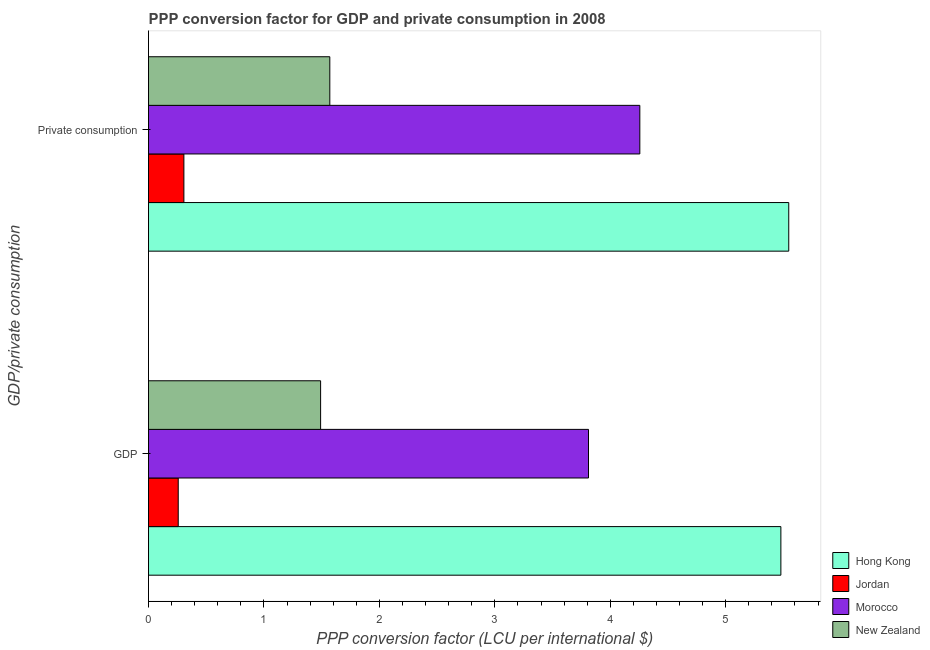How many different coloured bars are there?
Make the answer very short. 4. What is the label of the 1st group of bars from the top?
Your answer should be compact.  Private consumption. What is the ppp conversion factor for private consumption in Hong Kong?
Keep it short and to the point. 5.55. Across all countries, what is the maximum ppp conversion factor for private consumption?
Keep it short and to the point. 5.55. Across all countries, what is the minimum ppp conversion factor for private consumption?
Make the answer very short. 0.31. In which country was the ppp conversion factor for gdp maximum?
Offer a terse response. Hong Kong. In which country was the ppp conversion factor for gdp minimum?
Offer a very short reply. Jordan. What is the total ppp conversion factor for private consumption in the graph?
Offer a very short reply. 11.68. What is the difference between the ppp conversion factor for private consumption in New Zealand and that in Hong Kong?
Make the answer very short. -3.98. What is the difference between the ppp conversion factor for private consumption in Hong Kong and the ppp conversion factor for gdp in Jordan?
Your answer should be very brief. 5.29. What is the average ppp conversion factor for private consumption per country?
Give a very brief answer. 2.92. What is the difference between the ppp conversion factor for private consumption and ppp conversion factor for gdp in Hong Kong?
Offer a terse response. 0.07. In how many countries, is the ppp conversion factor for private consumption greater than 4.4 LCU?
Provide a succinct answer. 1. What is the ratio of the ppp conversion factor for private consumption in Jordan to that in New Zealand?
Make the answer very short. 0.2. In how many countries, is the ppp conversion factor for gdp greater than the average ppp conversion factor for gdp taken over all countries?
Offer a very short reply. 2. What does the 3rd bar from the top in  Private consumption represents?
Provide a short and direct response. Jordan. What does the 4th bar from the bottom in  Private consumption represents?
Keep it short and to the point. New Zealand. How many bars are there?
Ensure brevity in your answer.  8. Are all the bars in the graph horizontal?
Offer a very short reply. Yes. How many countries are there in the graph?
Ensure brevity in your answer.  4. What is the difference between two consecutive major ticks on the X-axis?
Ensure brevity in your answer.  1. How are the legend labels stacked?
Provide a succinct answer. Vertical. What is the title of the graph?
Provide a short and direct response. PPP conversion factor for GDP and private consumption in 2008. Does "St. Kitts and Nevis" appear as one of the legend labels in the graph?
Provide a succinct answer. No. What is the label or title of the X-axis?
Your answer should be very brief. PPP conversion factor (LCU per international $). What is the label or title of the Y-axis?
Provide a short and direct response. GDP/private consumption. What is the PPP conversion factor (LCU per international $) in Hong Kong in GDP?
Provide a succinct answer. 5.48. What is the PPP conversion factor (LCU per international $) of Jordan in GDP?
Make the answer very short. 0.26. What is the PPP conversion factor (LCU per international $) in Morocco in GDP?
Your response must be concise. 3.81. What is the PPP conversion factor (LCU per international $) in New Zealand in GDP?
Offer a very short reply. 1.49. What is the PPP conversion factor (LCU per international $) in Hong Kong in  Private consumption?
Make the answer very short. 5.55. What is the PPP conversion factor (LCU per international $) of Jordan in  Private consumption?
Make the answer very short. 0.31. What is the PPP conversion factor (LCU per international $) of Morocco in  Private consumption?
Ensure brevity in your answer.  4.26. What is the PPP conversion factor (LCU per international $) in New Zealand in  Private consumption?
Your answer should be very brief. 1.57. Across all GDP/private consumption, what is the maximum PPP conversion factor (LCU per international $) of Hong Kong?
Provide a succinct answer. 5.55. Across all GDP/private consumption, what is the maximum PPP conversion factor (LCU per international $) in Jordan?
Provide a short and direct response. 0.31. Across all GDP/private consumption, what is the maximum PPP conversion factor (LCU per international $) in Morocco?
Provide a succinct answer. 4.26. Across all GDP/private consumption, what is the maximum PPP conversion factor (LCU per international $) of New Zealand?
Your answer should be very brief. 1.57. Across all GDP/private consumption, what is the minimum PPP conversion factor (LCU per international $) in Hong Kong?
Keep it short and to the point. 5.48. Across all GDP/private consumption, what is the minimum PPP conversion factor (LCU per international $) in Jordan?
Offer a very short reply. 0.26. Across all GDP/private consumption, what is the minimum PPP conversion factor (LCU per international $) in Morocco?
Your response must be concise. 3.81. Across all GDP/private consumption, what is the minimum PPP conversion factor (LCU per international $) in New Zealand?
Offer a very short reply. 1.49. What is the total PPP conversion factor (LCU per international $) in Hong Kong in the graph?
Offer a terse response. 11.02. What is the total PPP conversion factor (LCU per international $) in Jordan in the graph?
Give a very brief answer. 0.56. What is the total PPP conversion factor (LCU per international $) of Morocco in the graph?
Offer a terse response. 8.07. What is the total PPP conversion factor (LCU per international $) in New Zealand in the graph?
Provide a short and direct response. 3.06. What is the difference between the PPP conversion factor (LCU per international $) of Hong Kong in GDP and that in  Private consumption?
Make the answer very short. -0.07. What is the difference between the PPP conversion factor (LCU per international $) of Jordan in GDP and that in  Private consumption?
Provide a short and direct response. -0.05. What is the difference between the PPP conversion factor (LCU per international $) of Morocco in GDP and that in  Private consumption?
Ensure brevity in your answer.  -0.44. What is the difference between the PPP conversion factor (LCU per international $) of New Zealand in GDP and that in  Private consumption?
Keep it short and to the point. -0.08. What is the difference between the PPP conversion factor (LCU per international $) in Hong Kong in GDP and the PPP conversion factor (LCU per international $) in Jordan in  Private consumption?
Ensure brevity in your answer.  5.17. What is the difference between the PPP conversion factor (LCU per international $) of Hong Kong in GDP and the PPP conversion factor (LCU per international $) of Morocco in  Private consumption?
Provide a succinct answer. 1.22. What is the difference between the PPP conversion factor (LCU per international $) in Hong Kong in GDP and the PPP conversion factor (LCU per international $) in New Zealand in  Private consumption?
Offer a very short reply. 3.91. What is the difference between the PPP conversion factor (LCU per international $) of Jordan in GDP and the PPP conversion factor (LCU per international $) of Morocco in  Private consumption?
Offer a very short reply. -4. What is the difference between the PPP conversion factor (LCU per international $) in Jordan in GDP and the PPP conversion factor (LCU per international $) in New Zealand in  Private consumption?
Offer a terse response. -1.31. What is the difference between the PPP conversion factor (LCU per international $) of Morocco in GDP and the PPP conversion factor (LCU per international $) of New Zealand in  Private consumption?
Provide a short and direct response. 2.24. What is the average PPP conversion factor (LCU per international $) in Hong Kong per GDP/private consumption?
Give a very brief answer. 5.51. What is the average PPP conversion factor (LCU per international $) in Jordan per GDP/private consumption?
Ensure brevity in your answer.  0.28. What is the average PPP conversion factor (LCU per international $) of Morocco per GDP/private consumption?
Your answer should be very brief. 4.03. What is the average PPP conversion factor (LCU per international $) in New Zealand per GDP/private consumption?
Your response must be concise. 1.53. What is the difference between the PPP conversion factor (LCU per international $) of Hong Kong and PPP conversion factor (LCU per international $) of Jordan in GDP?
Provide a short and direct response. 5.22. What is the difference between the PPP conversion factor (LCU per international $) of Hong Kong and PPP conversion factor (LCU per international $) of Morocco in GDP?
Offer a very short reply. 1.67. What is the difference between the PPP conversion factor (LCU per international $) in Hong Kong and PPP conversion factor (LCU per international $) in New Zealand in GDP?
Ensure brevity in your answer.  3.99. What is the difference between the PPP conversion factor (LCU per international $) in Jordan and PPP conversion factor (LCU per international $) in Morocco in GDP?
Ensure brevity in your answer.  -3.55. What is the difference between the PPP conversion factor (LCU per international $) in Jordan and PPP conversion factor (LCU per international $) in New Zealand in GDP?
Keep it short and to the point. -1.23. What is the difference between the PPP conversion factor (LCU per international $) of Morocco and PPP conversion factor (LCU per international $) of New Zealand in GDP?
Give a very brief answer. 2.32. What is the difference between the PPP conversion factor (LCU per international $) of Hong Kong and PPP conversion factor (LCU per international $) of Jordan in  Private consumption?
Keep it short and to the point. 5.24. What is the difference between the PPP conversion factor (LCU per international $) in Hong Kong and PPP conversion factor (LCU per international $) in Morocco in  Private consumption?
Your answer should be compact. 1.29. What is the difference between the PPP conversion factor (LCU per international $) in Hong Kong and PPP conversion factor (LCU per international $) in New Zealand in  Private consumption?
Provide a succinct answer. 3.98. What is the difference between the PPP conversion factor (LCU per international $) in Jordan and PPP conversion factor (LCU per international $) in Morocco in  Private consumption?
Your response must be concise. -3.95. What is the difference between the PPP conversion factor (LCU per international $) in Jordan and PPP conversion factor (LCU per international $) in New Zealand in  Private consumption?
Make the answer very short. -1.26. What is the difference between the PPP conversion factor (LCU per international $) in Morocco and PPP conversion factor (LCU per international $) in New Zealand in  Private consumption?
Ensure brevity in your answer.  2.69. What is the ratio of the PPP conversion factor (LCU per international $) in Jordan in GDP to that in  Private consumption?
Offer a terse response. 0.84. What is the ratio of the PPP conversion factor (LCU per international $) of Morocco in GDP to that in  Private consumption?
Keep it short and to the point. 0.9. What is the ratio of the PPP conversion factor (LCU per international $) of New Zealand in GDP to that in  Private consumption?
Make the answer very short. 0.95. What is the difference between the highest and the second highest PPP conversion factor (LCU per international $) of Hong Kong?
Make the answer very short. 0.07. What is the difference between the highest and the second highest PPP conversion factor (LCU per international $) in Jordan?
Offer a very short reply. 0.05. What is the difference between the highest and the second highest PPP conversion factor (LCU per international $) of Morocco?
Ensure brevity in your answer.  0.44. What is the difference between the highest and the second highest PPP conversion factor (LCU per international $) in New Zealand?
Ensure brevity in your answer.  0.08. What is the difference between the highest and the lowest PPP conversion factor (LCU per international $) of Hong Kong?
Your response must be concise. 0.07. What is the difference between the highest and the lowest PPP conversion factor (LCU per international $) of Jordan?
Provide a short and direct response. 0.05. What is the difference between the highest and the lowest PPP conversion factor (LCU per international $) in Morocco?
Keep it short and to the point. 0.44. What is the difference between the highest and the lowest PPP conversion factor (LCU per international $) of New Zealand?
Your answer should be very brief. 0.08. 